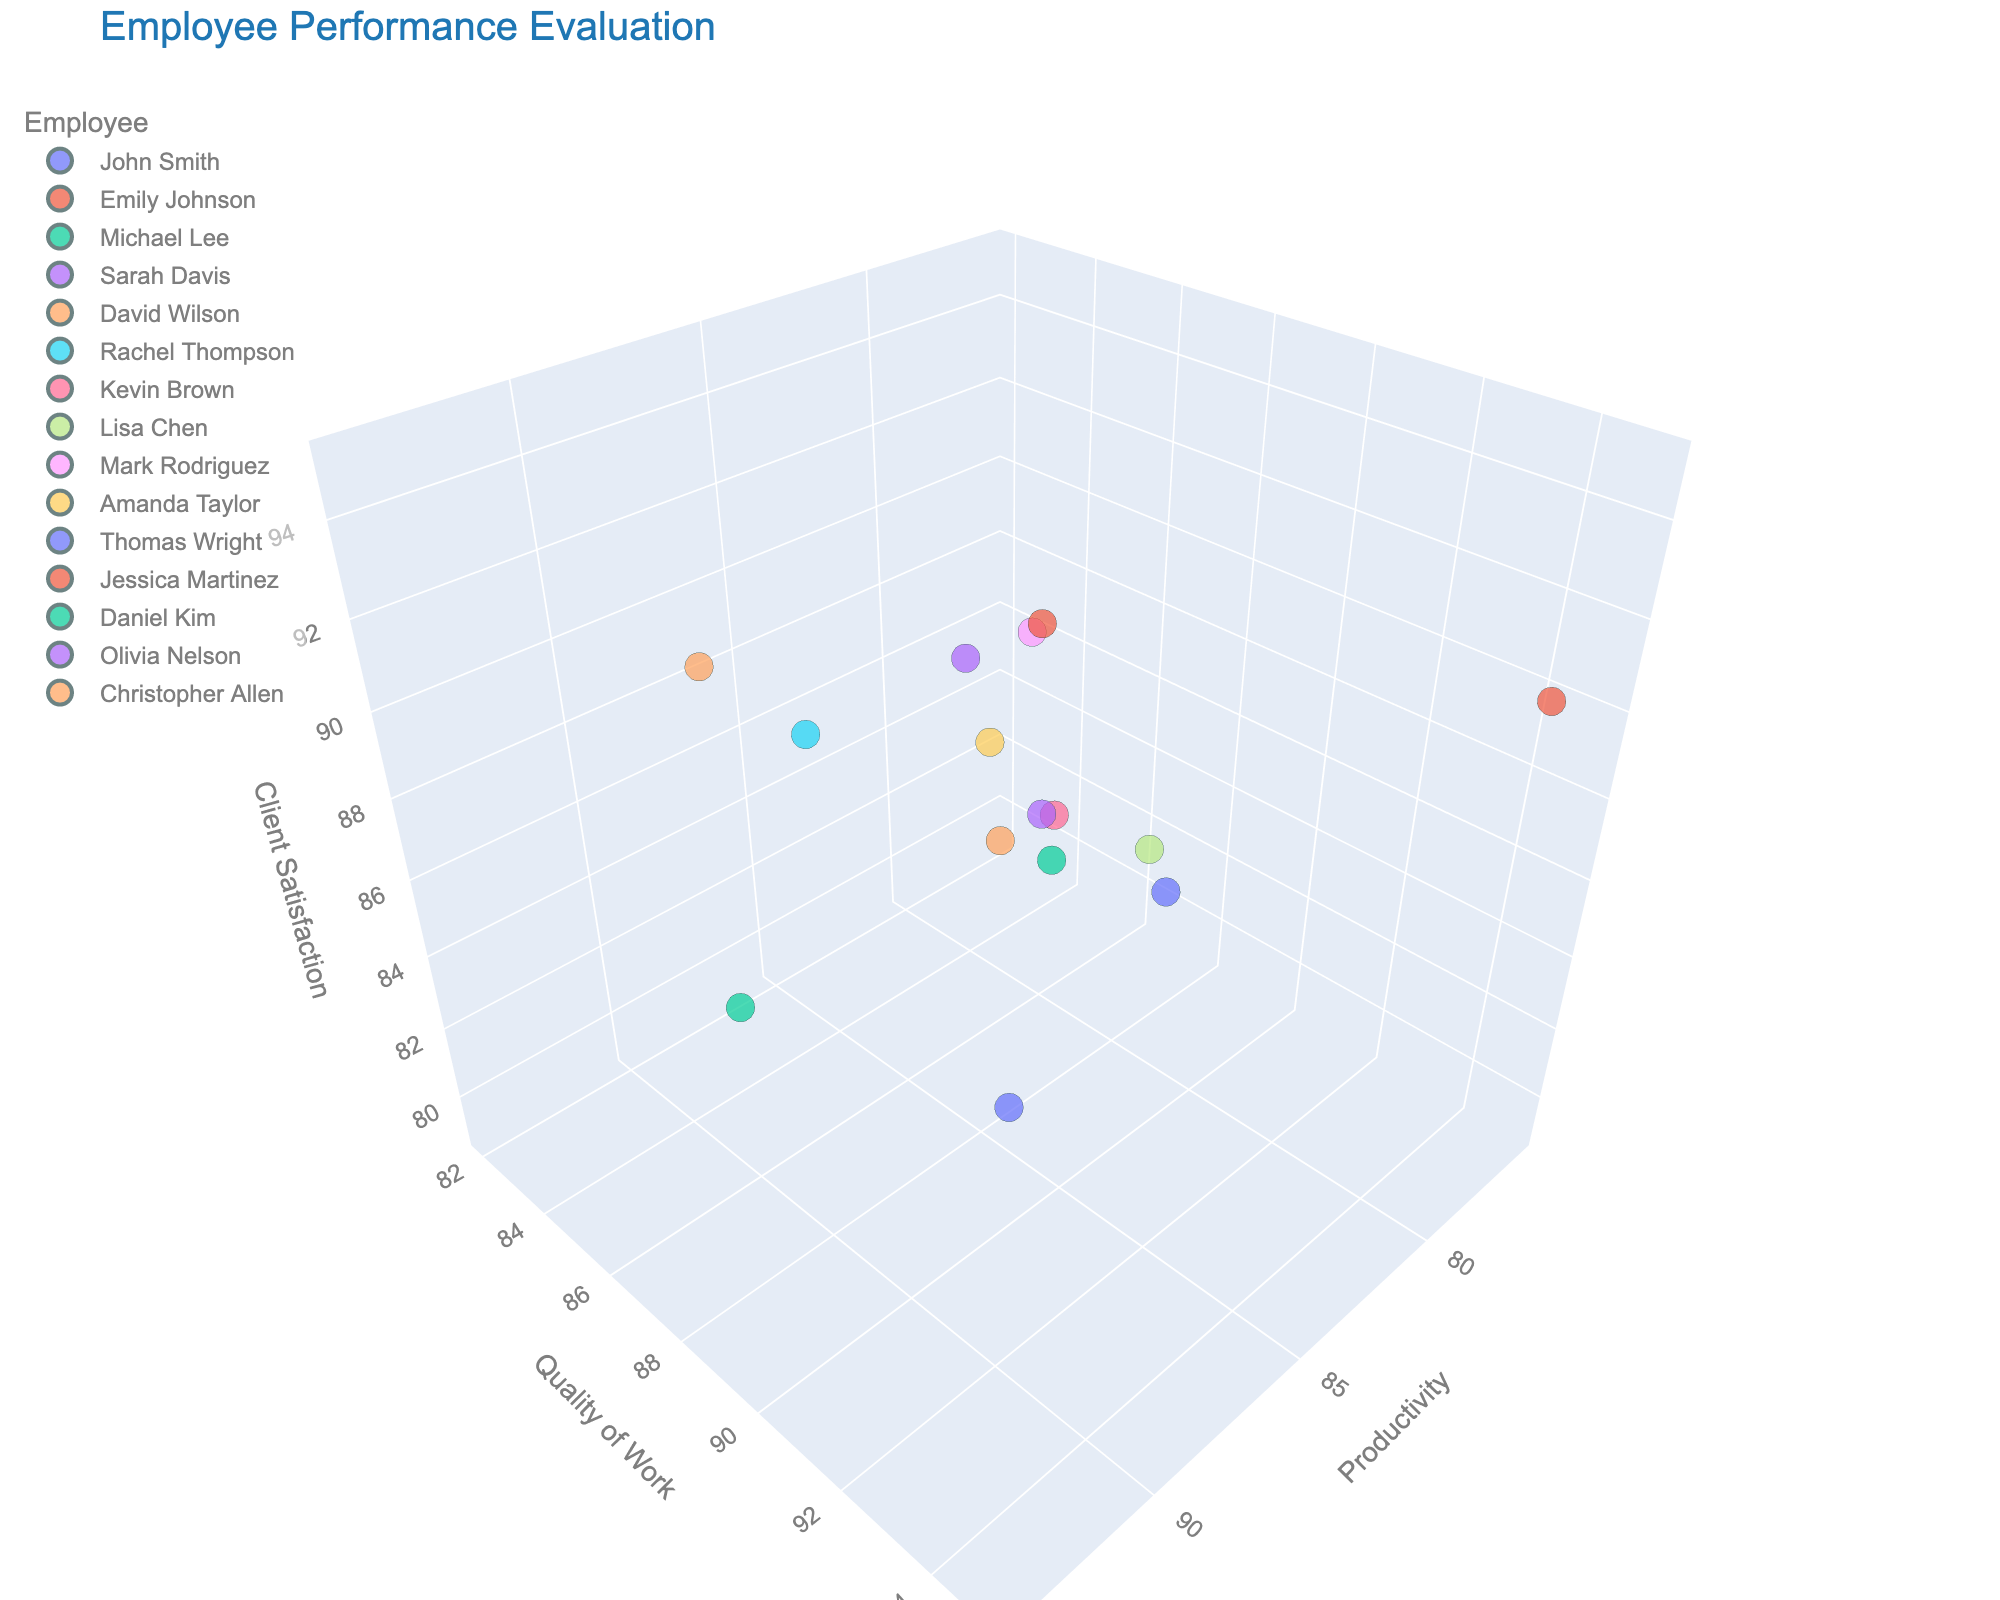What is the title of the figure? The title is usually displayed at the top of the figure. Here, the title indicates the overall purpose of the graph.
Answer: Employee Performance Evaluation How many data points are represented in the figure? Count the number of different dots in the plot, with each dot representing one employee. There are 15 employees listed.
Answer: 15 Which employee has the highest client satisfaction rating? Look at the Client Satisfaction axis (z-axis) and find the point that is placed highest along this axis. The employee corresponding to this point is Christopher Allen.
Answer: Christopher Allen Does anyone have higher quality scores than Productivity scores? Compare the x-axis (Productivity) and y-axis (Quality of Work) for each data point. You can see that employees like Emily Johnson, Lisa Chen, and Thomas Wright have higher Quality scores compared to Productivity scores.
Answer: Yes, Emily Johnson, Lisa Chen, and Thomas Wright Who has the lowest productivity score? Look at the x-axis (Productivity) and find the lowest point. The employee corresponding to this point is David Wilson.
Answer: David Wilson What's the average client satisfaction rating for employees whose productivity scores are above 90? Identify employees with productivity above 90 (Michael Lee, Rachel Thompson, Thomas Wright, and Christopher Allen) and calculate the average of their client satisfaction ratings: (86 + 94 + 87 + 95) / 4 = 90.5
Answer: 90.5 Compare the employees with the highest productivity score and the highest quality score. Who are they, and how do their other scores compare? The highest productivity score (94) belongs to Christopher Allen. The highest quality score (95) belongs to Emily Johnson. Comparing the other scores: Emily has a client satisfaction of 91 and productivity of 78 while Christopher has a quality of 90 and client satisfaction of 95.
Answer: Christopher Allen (Productivity), Emily Johnson (Quality); Christopher has lower quality, higher productivity, and higher client satisfaction Is there any employee who scores above 90 in all three metrics: productivity, quality, and client satisfaction? Check each employee's scores to see if all three metrics are above 90. Rachel Thompson scores 93 in Productivity, 91 in Quality, and 94 in Client Satisfaction.
Answer: Rachel Thompson Determine the employee with the highest combined score of productivity, quality, and client satisfaction. Sum the three metrics for each employee and find the highest total. Rachel Thompson: 93 + 91 + 94 = 278; others have lower combined scores.
Answer: Rachel Thompson Are there any outliers or clusters of employees based on their performance metrics? Identify any distinctly separated points or groups of points in the 3D space. For instance, Christopher Allen, Rachel Thompson form a high-performance cluster.
Answer: Yes, there are clusters 